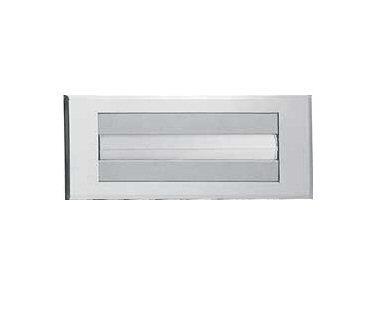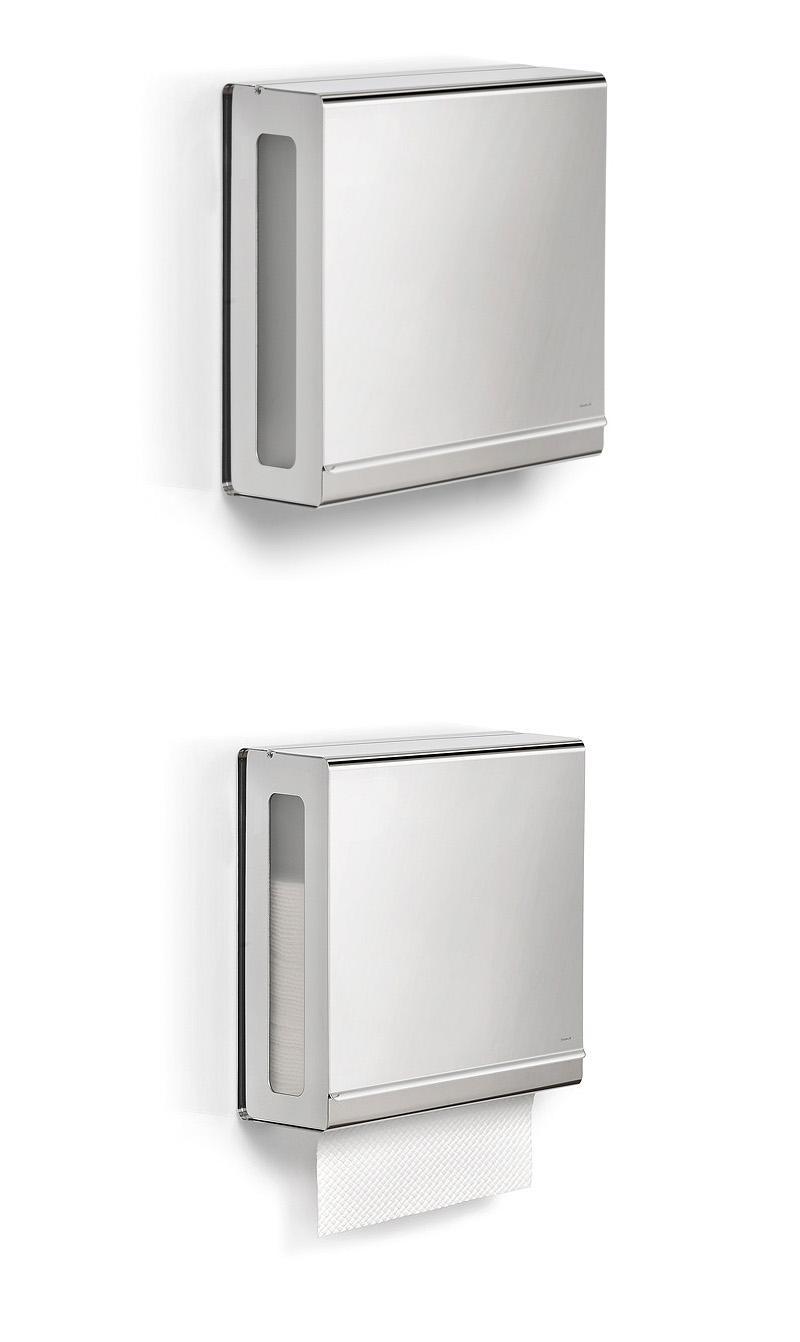The first image is the image on the left, the second image is the image on the right. Assess this claim about the two images: "At least one image shows exactly one clear rectangular tray-like container of folded paper towels.". Correct or not? Answer yes or no. No. The first image is the image on the left, the second image is the image on the right. Assess this claim about the two images: "There is not paper visible in the grey dispenser in the right.". Correct or not? Answer yes or no. No. 